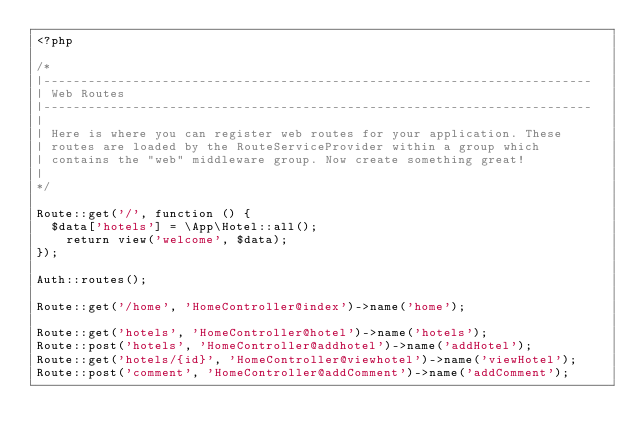<code> <loc_0><loc_0><loc_500><loc_500><_PHP_><?php

/*
|--------------------------------------------------------------------------
| Web Routes
|--------------------------------------------------------------------------
|
| Here is where you can register web routes for your application. These
| routes are loaded by the RouteServiceProvider within a group which
| contains the "web" middleware group. Now create something great!
|
*/

Route::get('/', function () {
	$data['hotels'] = \App\Hotel::all();
    return view('welcome', $data);
});

Auth::routes();

Route::get('/home', 'HomeController@index')->name('home');

Route::get('hotels', 'HomeController@hotel')->name('hotels');
Route::post('hotels', 'HomeController@addhotel')->name('addHotel');
Route::get('hotels/{id}', 'HomeController@viewhotel')->name('viewHotel');
Route::post('comment', 'HomeController@addComment')->name('addComment');
</code> 